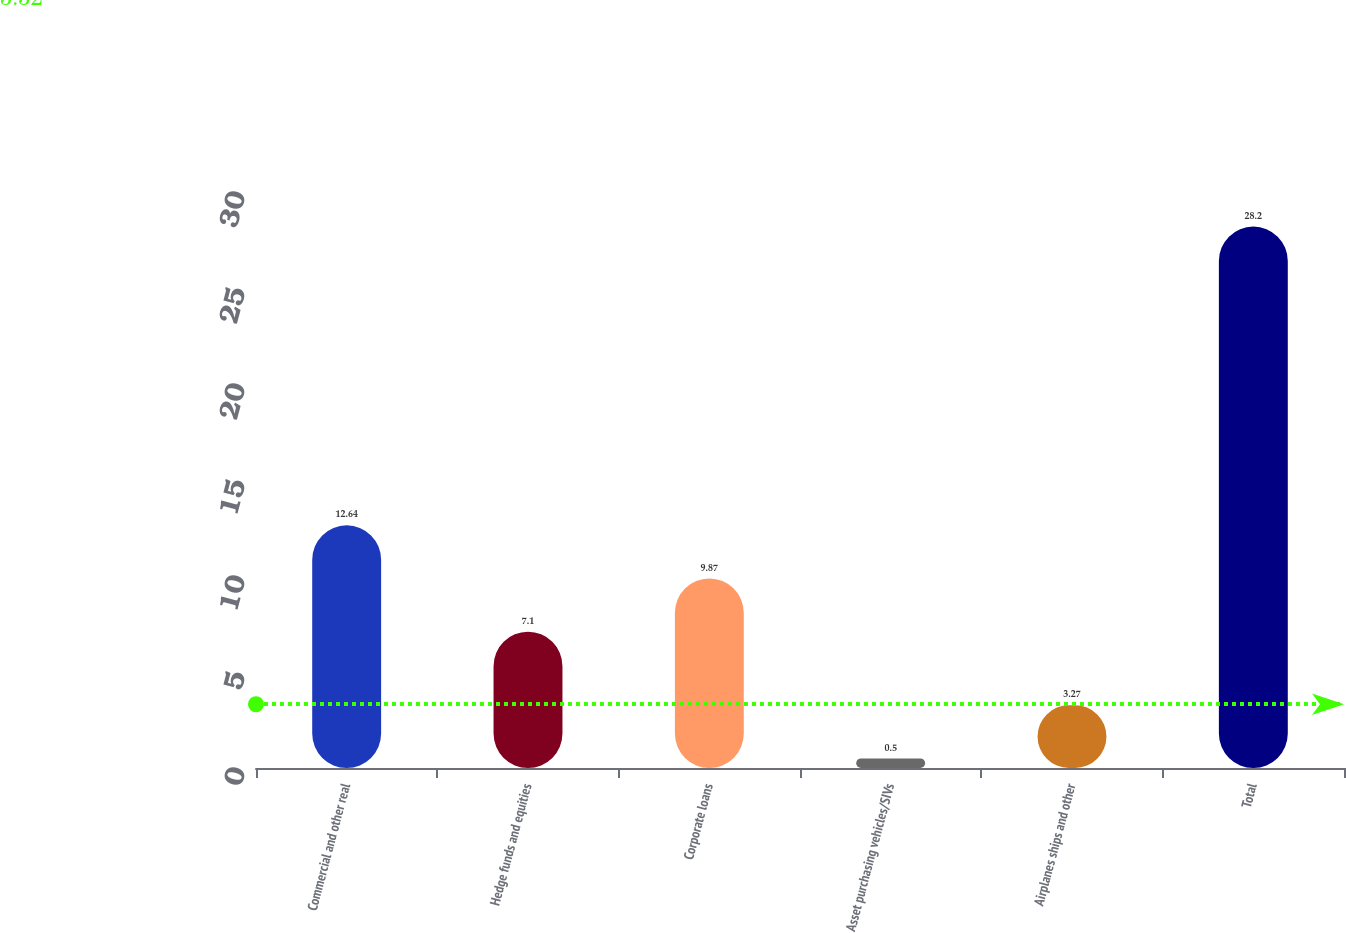<chart> <loc_0><loc_0><loc_500><loc_500><bar_chart><fcel>Commercial and other real<fcel>Hedge funds and equities<fcel>Corporate loans<fcel>Asset purchasing vehicles/SIVs<fcel>Airplanes ships and other<fcel>Total<nl><fcel>12.64<fcel>7.1<fcel>9.87<fcel>0.5<fcel>3.27<fcel>28.2<nl></chart> 